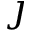<formula> <loc_0><loc_0><loc_500><loc_500>\jmath</formula> 